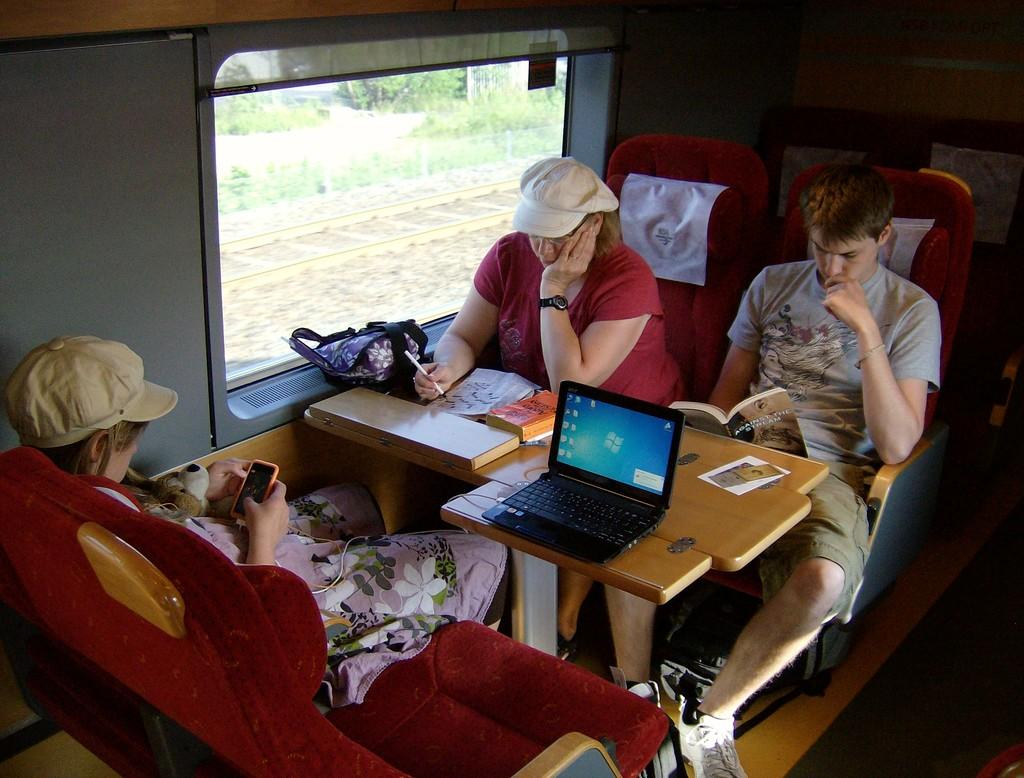How many people are in the image? There are three people in the image: a boy, a woman, and a guy. What are they doing in the image? They are sitting in a train. What can be seen in the train besides the people? There is a chair, a table, and a laptop on the table. Who is sitting on the chair? The guy is sitting on the chair. What type of yard can be seen through the window of the train in the image? There is no window or yard visible in the image; it only shows the people and objects inside the train. 